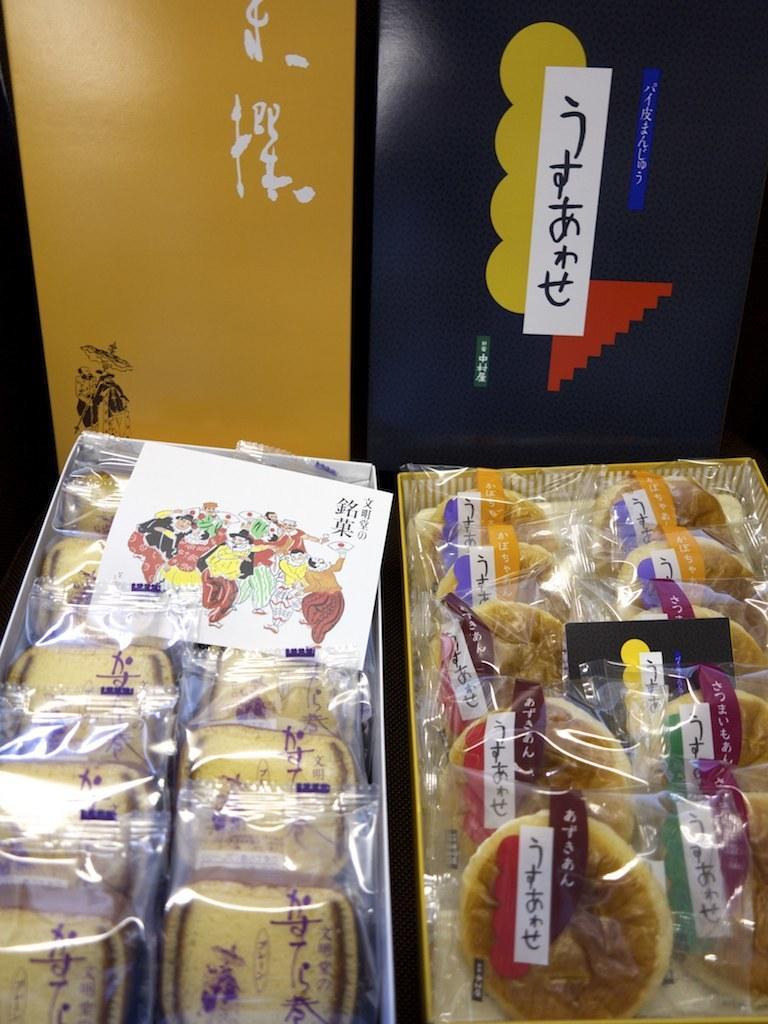In one or two sentences, can you explain what this image depicts? In this image at the bottom there are some boxes, in the boxes we could see some breads and buns. And also there are some papers in the boxes, in the background there are some boards. 